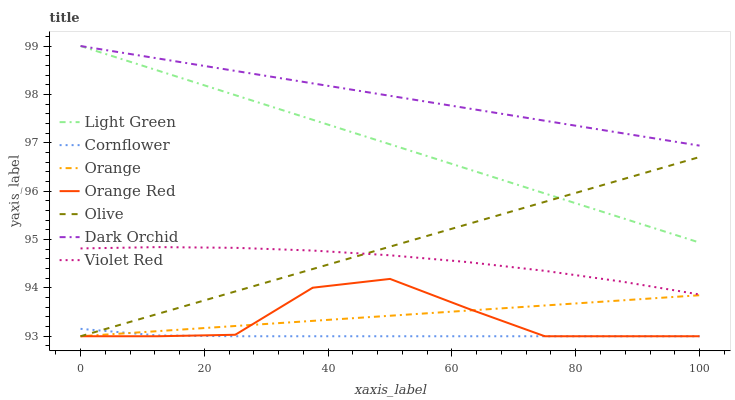Does Violet Red have the minimum area under the curve?
Answer yes or no. No. Does Violet Red have the maximum area under the curve?
Answer yes or no. No. Is Violet Red the smoothest?
Answer yes or no. No. Is Violet Red the roughest?
Answer yes or no. No. Does Violet Red have the lowest value?
Answer yes or no. No. Does Violet Red have the highest value?
Answer yes or no. No. Is Cornflower less than Light Green?
Answer yes or no. Yes. Is Light Green greater than Orange?
Answer yes or no. Yes. Does Cornflower intersect Light Green?
Answer yes or no. No. 